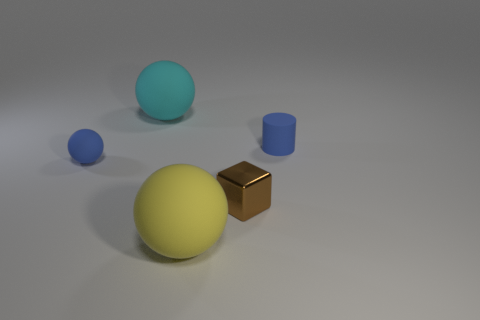Is the shape of the blue object that is to the right of the block the same as the yellow rubber object that is to the left of the brown thing?
Offer a very short reply. No. The yellow object that is the same shape as the big cyan matte thing is what size?
Give a very brief answer. Large. What number of big yellow objects are made of the same material as the big cyan thing?
Give a very brief answer. 1. What material is the big cyan thing?
Keep it short and to the point. Rubber. What shape is the tiny rubber object in front of the blue rubber thing that is on the right side of the big yellow object?
Make the answer very short. Sphere. There is a tiny blue rubber thing on the right side of the large cyan thing; what is its shape?
Make the answer very short. Cylinder. What number of blocks are the same color as the metal object?
Make the answer very short. 0. What color is the small cube?
Offer a very short reply. Brown. There is a large sphere behind the small blue ball; what number of large matte things are in front of it?
Provide a succinct answer. 1. There is a yellow matte ball; is it the same size as the blue object that is on the right side of the metal block?
Keep it short and to the point. No. 